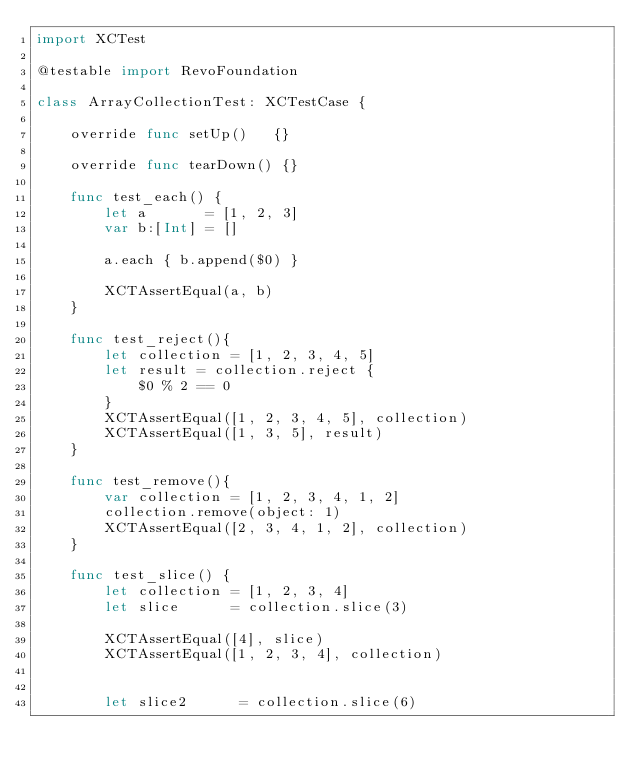Convert code to text. <code><loc_0><loc_0><loc_500><loc_500><_Swift_>import XCTest

@testable import RevoFoundation

class ArrayCollectionTest: XCTestCase {

    override func setUp()   {}

    override func tearDown() {}

    func test_each() {
        let a       = [1, 2, 3]
        var b:[Int] = []
        
        a.each { b.append($0) }
        
        XCTAssertEqual(a, b)
    }

    func test_reject(){
        let collection = [1, 2, 3, 4, 5]
        let result = collection.reject {
            $0 % 2 == 0
        }
        XCTAssertEqual([1, 2, 3, 4, 5], collection)
        XCTAssertEqual([1, 3, 5], result)
    }
    
    func test_remove(){
        var collection = [1, 2, 3, 4, 1, 2]
        collection.remove(object: 1)
        XCTAssertEqual([2, 3, 4, 1, 2], collection)
    }
    
    func test_slice() {
        let collection = [1, 2, 3, 4]
        let slice      = collection.slice(3)
        
        XCTAssertEqual([4], slice)
        XCTAssertEqual([1, 2, 3, 4], collection)
        
        
        let slice2      = collection.slice(6)</code> 